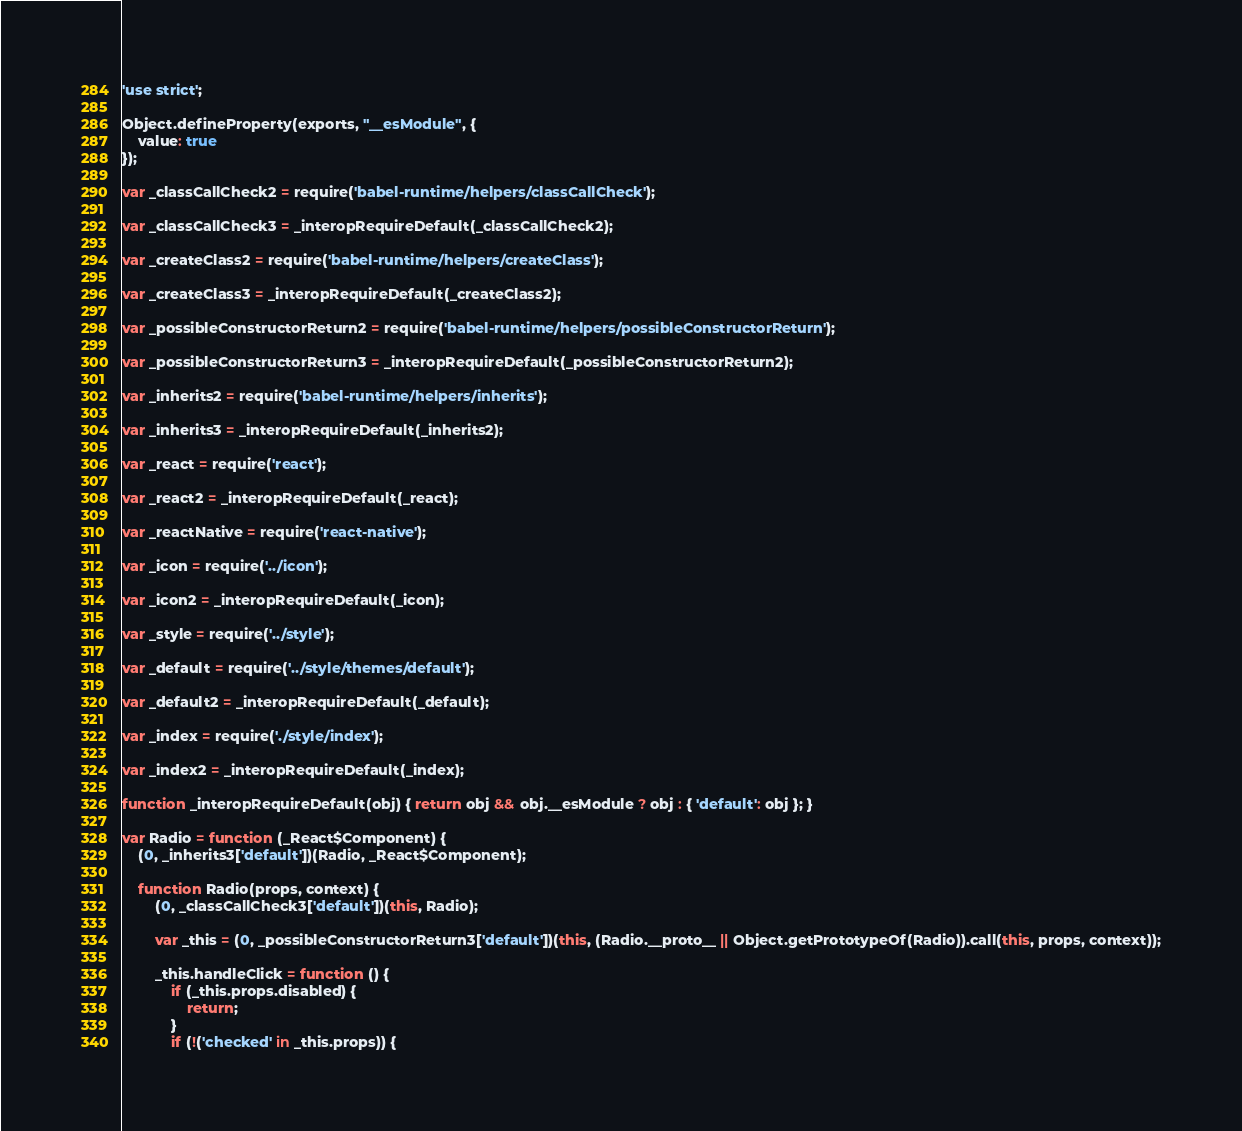Convert code to text. <code><loc_0><loc_0><loc_500><loc_500><_JavaScript_>'use strict';

Object.defineProperty(exports, "__esModule", {
    value: true
});

var _classCallCheck2 = require('babel-runtime/helpers/classCallCheck');

var _classCallCheck3 = _interopRequireDefault(_classCallCheck2);

var _createClass2 = require('babel-runtime/helpers/createClass');

var _createClass3 = _interopRequireDefault(_createClass2);

var _possibleConstructorReturn2 = require('babel-runtime/helpers/possibleConstructorReturn');

var _possibleConstructorReturn3 = _interopRequireDefault(_possibleConstructorReturn2);

var _inherits2 = require('babel-runtime/helpers/inherits');

var _inherits3 = _interopRequireDefault(_inherits2);

var _react = require('react');

var _react2 = _interopRequireDefault(_react);

var _reactNative = require('react-native');

var _icon = require('../icon');

var _icon2 = _interopRequireDefault(_icon);

var _style = require('../style');

var _default = require('../style/themes/default');

var _default2 = _interopRequireDefault(_default);

var _index = require('./style/index');

var _index2 = _interopRequireDefault(_index);

function _interopRequireDefault(obj) { return obj && obj.__esModule ? obj : { 'default': obj }; }

var Radio = function (_React$Component) {
    (0, _inherits3['default'])(Radio, _React$Component);

    function Radio(props, context) {
        (0, _classCallCheck3['default'])(this, Radio);

        var _this = (0, _possibleConstructorReturn3['default'])(this, (Radio.__proto__ || Object.getPrototypeOf(Radio)).call(this, props, context));

        _this.handleClick = function () {
            if (_this.props.disabled) {
                return;
            }
            if (!('checked' in _this.props)) {</code> 